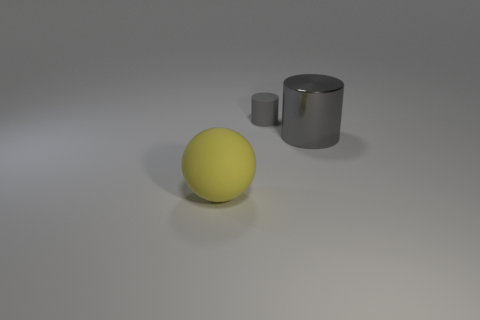There is a rubber object that is behind the big ball; is its color the same as the large thing on the right side of the large rubber sphere?
Your answer should be very brief. Yes. There is a gray thing left of the shiny cylinder; is its size the same as the gray metal thing?
Provide a short and direct response. No. What number of cylinders are the same size as the yellow rubber thing?
Keep it short and to the point. 1. The other thing that is the same color as the tiny matte object is what size?
Ensure brevity in your answer.  Large. Do the matte cylinder and the large sphere have the same color?
Your answer should be very brief. No. What shape is the big metal thing?
Offer a terse response. Cylinder. Is there a big metallic cylinder of the same color as the matte cylinder?
Give a very brief answer. Yes. Is the number of small gray rubber objects that are in front of the small gray matte cylinder greater than the number of large yellow things?
Your response must be concise. No. Do the yellow matte object and the rubber thing that is behind the gray metallic cylinder have the same shape?
Provide a short and direct response. No. Are any tiny gray objects visible?
Ensure brevity in your answer.  Yes. 